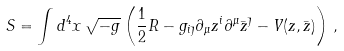Convert formula to latex. <formula><loc_0><loc_0><loc_500><loc_500>S = \int d ^ { 4 } x \, \sqrt { - g } \left ( \frac { 1 } { 2 } R - g _ { i \bar { \jmath } } \partial _ { \mu } z ^ { i } \partial ^ { \mu } \bar { z } ^ { \bar { \jmath } } - V ( z , \bar { z } ) \right ) \, ,</formula> 